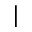<formula> <loc_0><loc_0><loc_500><loc_500>|</formula> 